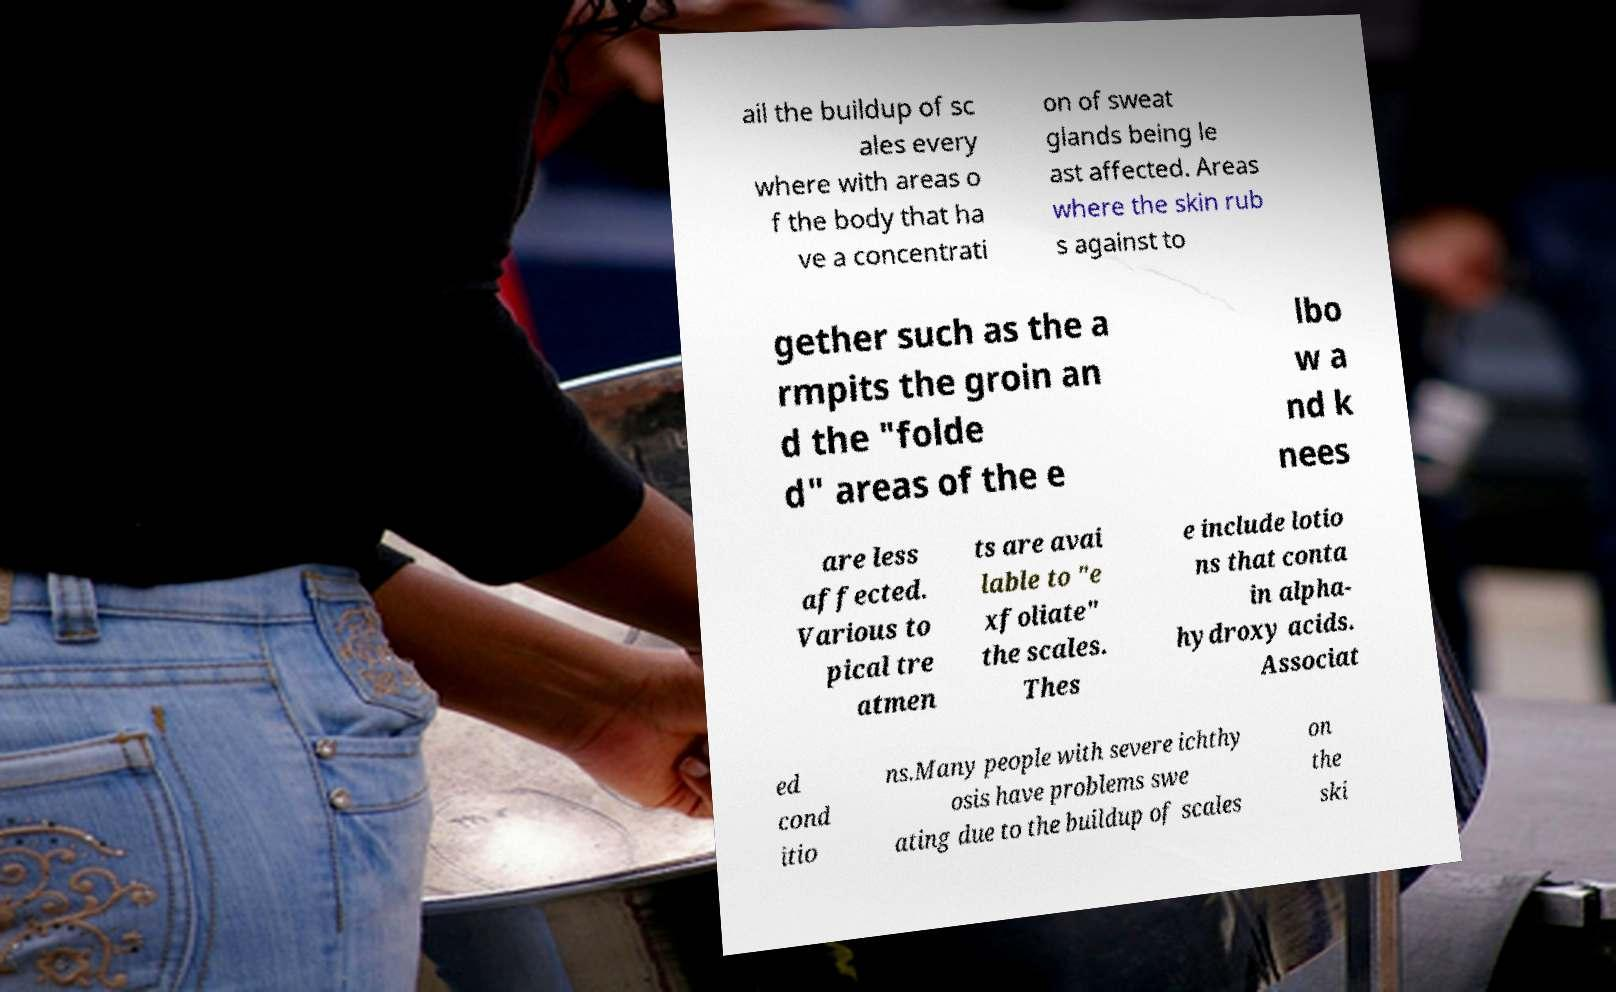I need the written content from this picture converted into text. Can you do that? ail the buildup of sc ales every where with areas o f the body that ha ve a concentrati on of sweat glands being le ast affected. Areas where the skin rub s against to gether such as the a rmpits the groin an d the "folde d" areas of the e lbo w a nd k nees are less affected. Various to pical tre atmen ts are avai lable to "e xfoliate" the scales. Thes e include lotio ns that conta in alpha- hydroxy acids. Associat ed cond itio ns.Many people with severe ichthy osis have problems swe ating due to the buildup of scales on the ski 